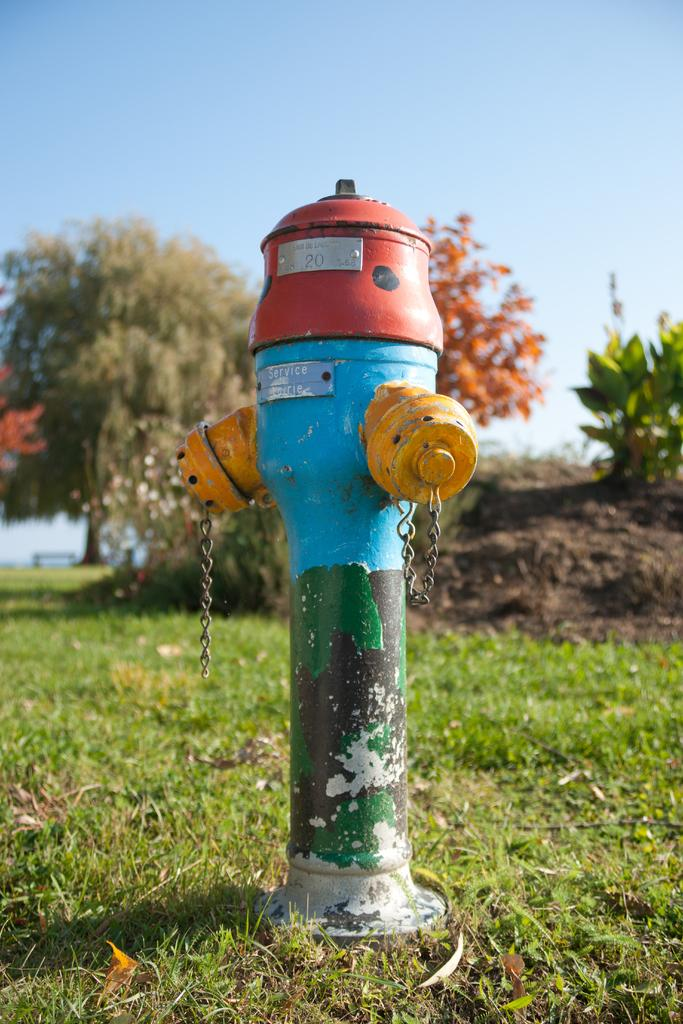Provide a one-sentence caption for the provided image. A colorful painted fire hydrant with #20 and Service on the side. 